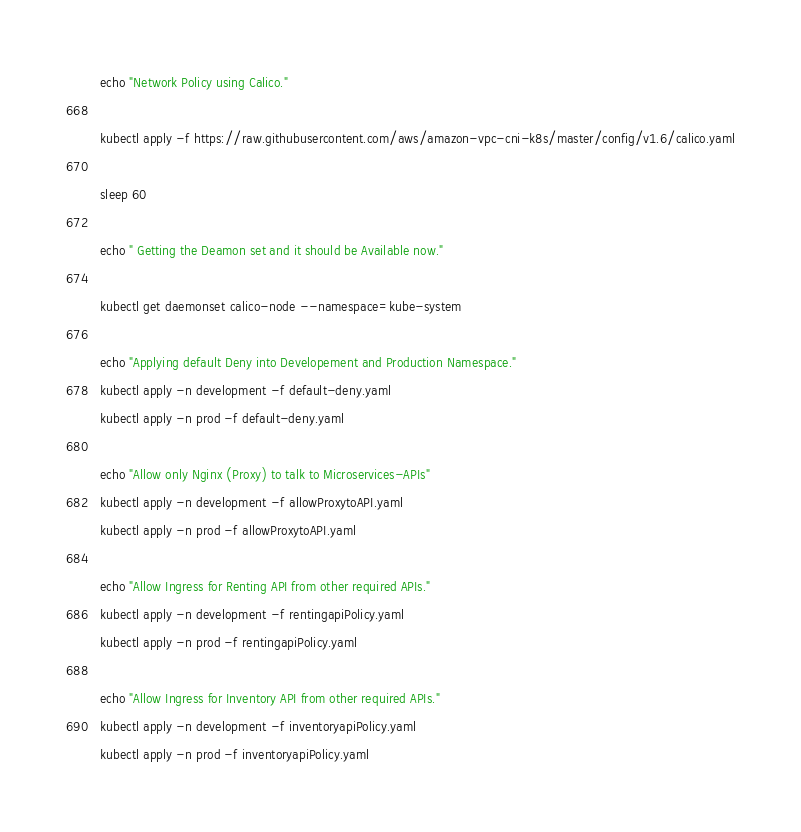<code> <loc_0><loc_0><loc_500><loc_500><_Bash_>echo "Network Policy using Calico."

kubectl apply -f https://raw.githubusercontent.com/aws/amazon-vpc-cni-k8s/master/config/v1.6/calico.yaml

sleep 60

echo " Getting the Deamon set and it should be Available now."

kubectl get daemonset calico-node --namespace=kube-system

echo "Applying default Deny into Developement and Production Namespace."
kubectl apply -n development -f default-deny.yaml
kubectl apply -n prod -f default-deny.yaml

echo "Allow only Nginx (Proxy) to talk to Microservices-APIs"
kubectl apply -n development -f allowProxytoAPI.yaml
kubectl apply -n prod -f allowProxytoAPI.yaml

echo "Allow Ingress for Renting API from other required APIs."
kubectl apply -n development -f rentingapiPolicy.yaml
kubectl apply -n prod -f rentingapiPolicy.yaml

echo "Allow Ingress for Inventory API from other required APIs."
kubectl apply -n development -f inventoryapiPolicy.yaml
kubectl apply -n prod -f inventoryapiPolicy.yaml</code> 